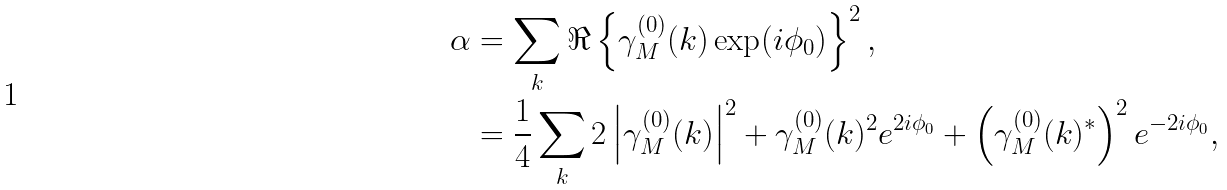<formula> <loc_0><loc_0><loc_500><loc_500>\alpha & = \sum _ { k } \Re \left \{ \gamma _ { M } ^ { ( 0 ) } ( k ) \exp ( i \phi _ { 0 } ) \right \} ^ { 2 } , \\ & = \frac { 1 } { 4 } \sum _ { k } 2 \left | \gamma _ { M } ^ { ( 0 ) } ( k ) \right | ^ { 2 } + \gamma _ { M } ^ { ( 0 ) } ( k ) ^ { 2 } e ^ { 2 i \phi _ { 0 } } + \left ( \gamma _ { M } ^ { ( 0 ) } ( k ) ^ { * } \right ) ^ { 2 } e ^ { - 2 i \phi _ { 0 } } ,</formula> 